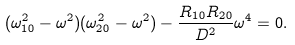Convert formula to latex. <formula><loc_0><loc_0><loc_500><loc_500>( \omega _ { 1 0 } ^ { 2 } - \omega ^ { 2 } ) ( \omega _ { 2 0 } ^ { 2 } - \omega ^ { 2 } ) - \frac { R _ { 1 0 } R _ { 2 0 } } { D ^ { 2 } } \omega ^ { 4 } = 0 .</formula> 